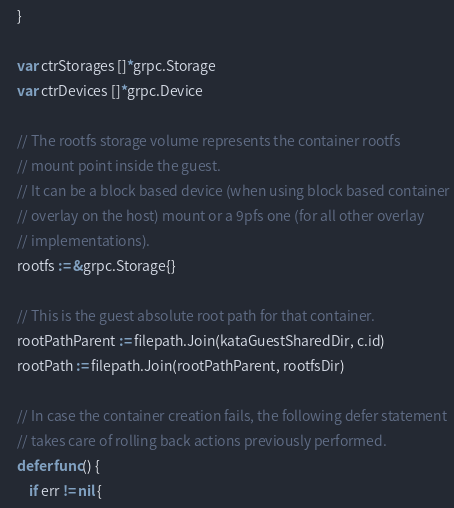<code> <loc_0><loc_0><loc_500><loc_500><_Go_>	}

	var ctrStorages []*grpc.Storage
	var ctrDevices []*grpc.Device

	// The rootfs storage volume represents the container rootfs
	// mount point inside the guest.
	// It can be a block based device (when using block based container
	// overlay on the host) mount or a 9pfs one (for all other overlay
	// implementations).
	rootfs := &grpc.Storage{}

	// This is the guest absolute root path for that container.
	rootPathParent := filepath.Join(kataGuestSharedDir, c.id)
	rootPath := filepath.Join(rootPathParent, rootfsDir)

	// In case the container creation fails, the following defer statement
	// takes care of rolling back actions previously performed.
	defer func() {
		if err != nil {</code> 